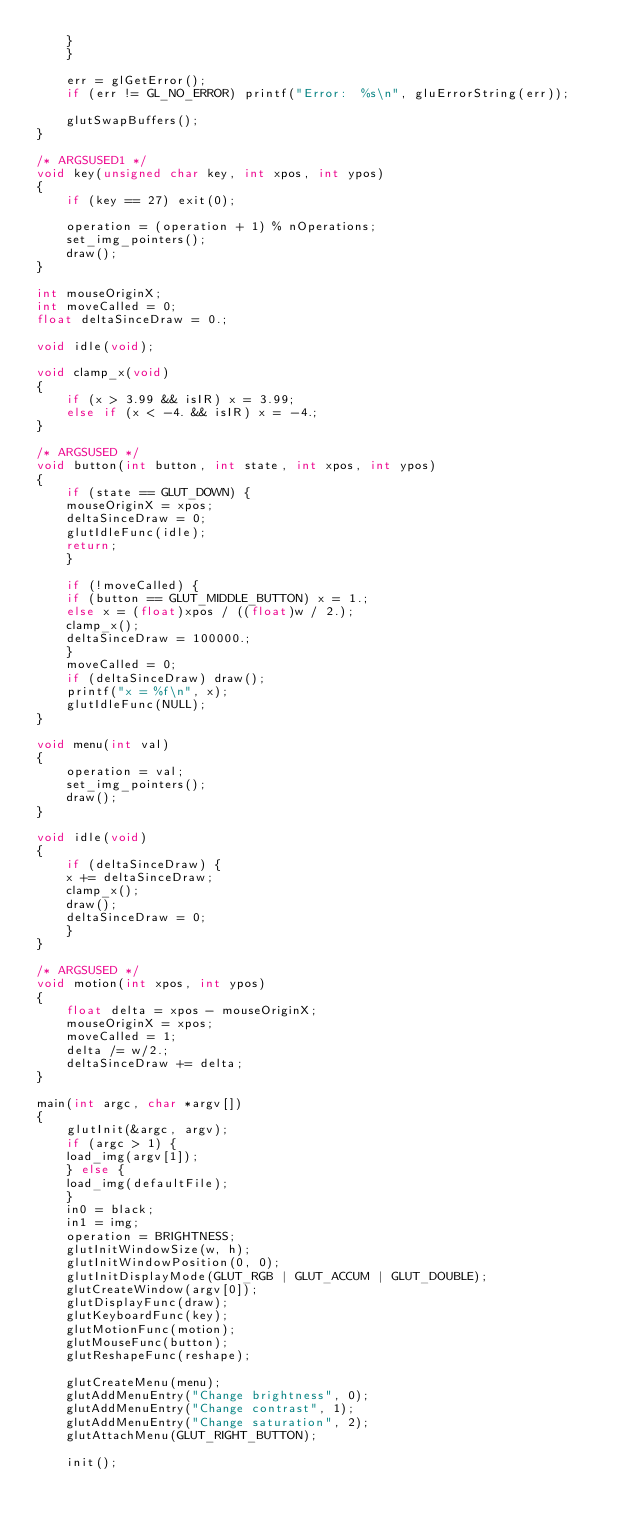Convert code to text. <code><loc_0><loc_0><loc_500><loc_500><_C_>	}
    }

    err = glGetError();
    if (err != GL_NO_ERROR) printf("Error:  %s\n", gluErrorString(err));

    glutSwapBuffers();
}

/* ARGSUSED1 */
void key(unsigned char key, int xpos, int ypos)
{
    if (key == 27) exit(0);

    operation = (operation + 1) % nOperations;
    set_img_pointers();
    draw();
}

int mouseOriginX;
int moveCalled = 0;
float deltaSinceDraw = 0.;

void idle(void);

void clamp_x(void)
{
    if (x > 3.99 && isIR) x = 3.99;
    else if (x < -4. && isIR) x = -4.;
}

/* ARGSUSED */
void button(int button, int state, int xpos, int ypos)
{
    if (state == GLUT_DOWN) {
	mouseOriginX = xpos;
	deltaSinceDraw = 0;
	glutIdleFunc(idle);
	return;
    }

    if (!moveCalled) {
	if (button == GLUT_MIDDLE_BUTTON) x = 1.;
	else x = (float)xpos / ((float)w / 2.);
	clamp_x();
	deltaSinceDraw = 100000.;
    } 
    moveCalled = 0;
    if (deltaSinceDraw) draw();
    printf("x = %f\n", x);
    glutIdleFunc(NULL);
}

void menu(int val) 
{
    operation = val;
    set_img_pointers();
    draw();
}

void idle(void)
{
    if (deltaSinceDraw) {
	x += deltaSinceDraw;
	clamp_x();
	draw();
	deltaSinceDraw = 0;
    }
}

/* ARGSUSED */
void motion(int xpos, int ypos)
{
    float delta = xpos - mouseOriginX;
    mouseOriginX = xpos;
    moveCalled = 1;
    delta /= w/2.;
    deltaSinceDraw += delta;
}

main(int argc, char *argv[])
{
    glutInit(&argc, argv);
    if (argc > 1) {
	load_img(argv[1]);
    } else {
	load_img(defaultFile);
    }
    in0 = black;
    in1 = img;
    operation = BRIGHTNESS;
    glutInitWindowSize(w, h);
    glutInitWindowPosition(0, 0);
    glutInitDisplayMode(GLUT_RGB | GLUT_ACCUM | GLUT_DOUBLE);
    glutCreateWindow(argv[0]);
    glutDisplayFunc(draw);
    glutKeyboardFunc(key);
    glutMotionFunc(motion);
    glutMouseFunc(button);
    glutReshapeFunc(reshape);

    glutCreateMenu(menu);
    glutAddMenuEntry("Change brightness", 0);
    glutAddMenuEntry("Change contrast", 1);
    glutAddMenuEntry("Change saturation", 2);
    glutAttachMenu(GLUT_RIGHT_BUTTON);

    init();
</code> 